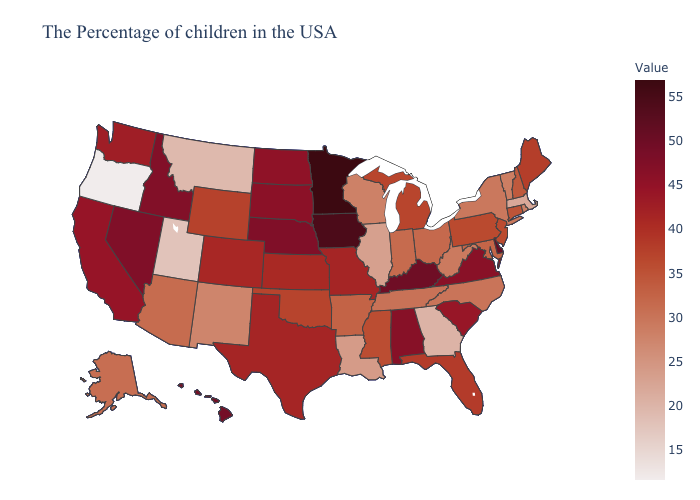Is the legend a continuous bar?
Quick response, please. Yes. Is the legend a continuous bar?
Answer briefly. Yes. Does West Virginia have the lowest value in the USA?
Short answer required. No. Does Oregon have the lowest value in the USA?
Concise answer only. Yes. Does the map have missing data?
Short answer required. No. Which states have the lowest value in the USA?
Concise answer only. Oregon. Does Illinois have the lowest value in the MidWest?
Write a very short answer. Yes. Does New Mexico have the highest value in the West?
Quick response, please. No. Which states have the lowest value in the USA?
Short answer required. Oregon. Is the legend a continuous bar?
Short answer required. Yes. Does Nevada have a lower value than Iowa?
Short answer required. Yes. 